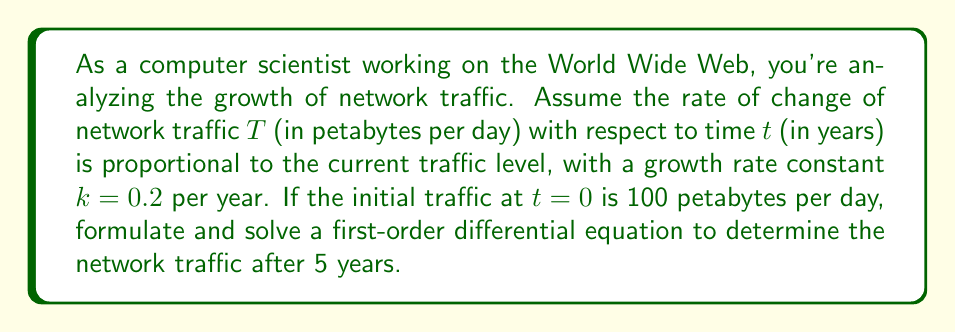Provide a solution to this math problem. Let's approach this step-by-step:

1) First, we formulate the differential equation. The rate of change of traffic with respect to time is proportional to the current traffic level:

   $$\frac{dT}{dt} = kT$$

   where $k = 0.2$ is the growth rate constant.

2) This is a separable first-order differential equation. We can solve it by separating variables:

   $$\frac{dT}{T} = k dt$$

3) Integrating both sides:

   $$\int \frac{dT}{T} = \int k dt$$

   $$\ln|T| = kt + C$$

   where $C$ is the constant of integration.

4) Taking the exponential of both sides:

   $$T = e^{kt + C} = e^C e^{kt} = Ae^{kt}$$

   where $A = e^C$ is a new constant.

5) To find $A$, we use the initial condition. At $t=0$, $T=100$:

   $$100 = Ae^{k(0)} = A$$

6) Therefore, our solution is:

   $$T = 100e^{0.2t}$$

7) To find the traffic after 5 years, we substitute $t=5$:

   $$T(5) = 100e^{0.2(5)} = 100e^1 = 100e \approx 271.83$$

Thus, after 5 years, the network traffic will be approximately 271.83 petabytes per day.
Answer: The network traffic after 5 years will be approximately 271.83 petabytes per day. 